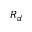Convert formula to latex. <formula><loc_0><loc_0><loc_500><loc_500>R _ { d }</formula> 